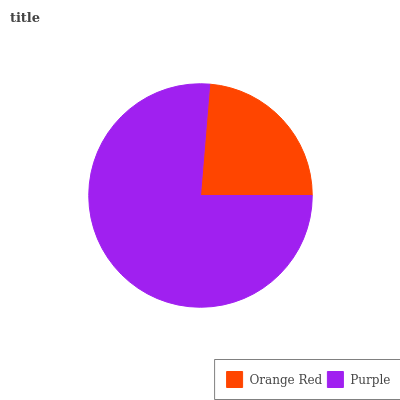Is Orange Red the minimum?
Answer yes or no. Yes. Is Purple the maximum?
Answer yes or no. Yes. Is Purple the minimum?
Answer yes or no. No. Is Purple greater than Orange Red?
Answer yes or no. Yes. Is Orange Red less than Purple?
Answer yes or no. Yes. Is Orange Red greater than Purple?
Answer yes or no. No. Is Purple less than Orange Red?
Answer yes or no. No. Is Purple the high median?
Answer yes or no. Yes. Is Orange Red the low median?
Answer yes or no. Yes. Is Orange Red the high median?
Answer yes or no. No. Is Purple the low median?
Answer yes or no. No. 